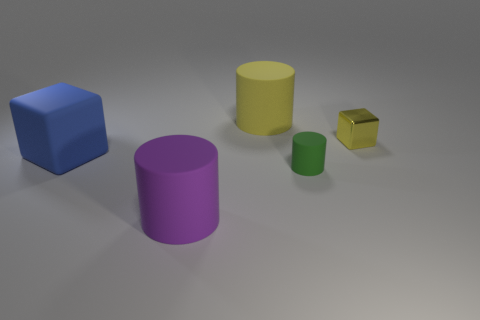Add 1 big yellow cylinders. How many objects exist? 6 Subtract all cubes. How many objects are left? 3 Subtract 1 blue cubes. How many objects are left? 4 Subtract all tiny yellow matte objects. Subtract all big purple matte cylinders. How many objects are left? 4 Add 3 tiny yellow blocks. How many tiny yellow blocks are left? 4 Add 3 big red rubber cylinders. How many big red rubber cylinders exist? 3 